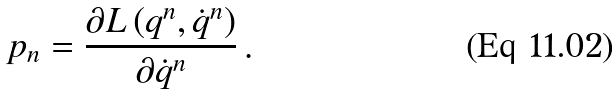<formula> <loc_0><loc_0><loc_500><loc_500>p _ { n } = \frac { \partial L \left ( q ^ { n } , \dot { q } ^ { n } \right ) } { \partial \dot { q } ^ { n } } \, .</formula> 